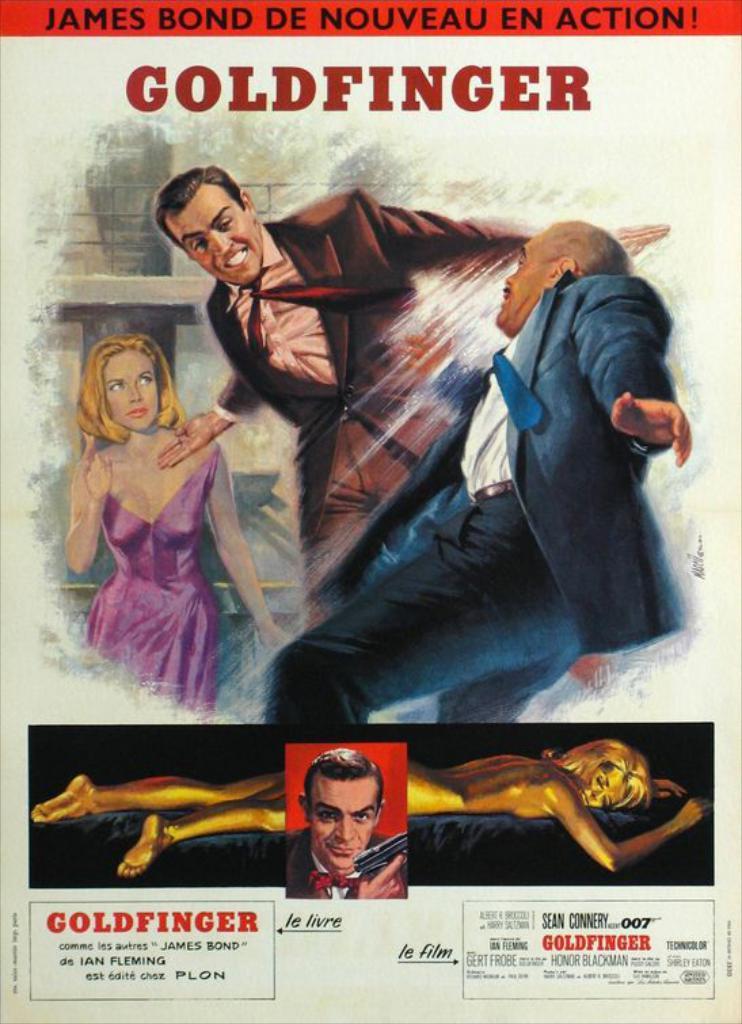What color finger is mentioned?
Ensure brevity in your answer.  Gold. Who plays james bond in this movie?
Your answer should be very brief. Sean connery. 